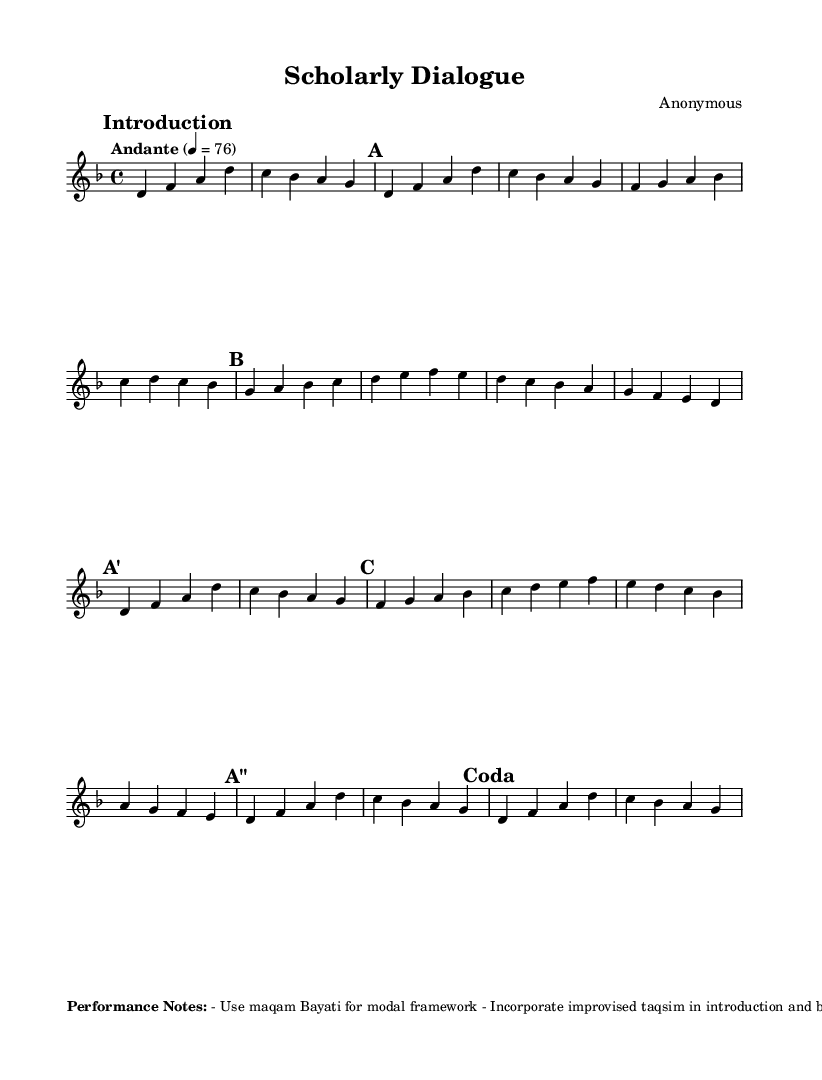What is the key signature of this music? The key signature is indicated by the presence of a flat that signifies B flat, meaning it is in D minor which has one flat (B flat).
Answer: D minor What is the time signature of this music? The time signature is displayed at the beginning of the staff and shows that there are four beats per measure, specifically in a 4/4 format.
Answer: 4/4 What is the tempo marking of this music? The tempo is defined as "Andante," which signifies a moderate walking pace, associated with a specific metronome marking of 76 beats per minute.
Answer: Andante How many sections are there in the music? The music consists of 5 distinct sections labeled A, B, C, along with two abbreviated forms of A, namely A' and A''.
Answer: 5 What modal framework is recommended for this performance? The performance notes specify the use of maqam Bayati as the modal framework, which is characteristic of Middle Eastern music.
Answer: Maqam Bayati What do the performance notes suggest about improvisation? The performance notes mention incorporating improvised taqsim, indicating the importance of personal expression and improvisation in the piece.
Answer: Improvised taqsim 